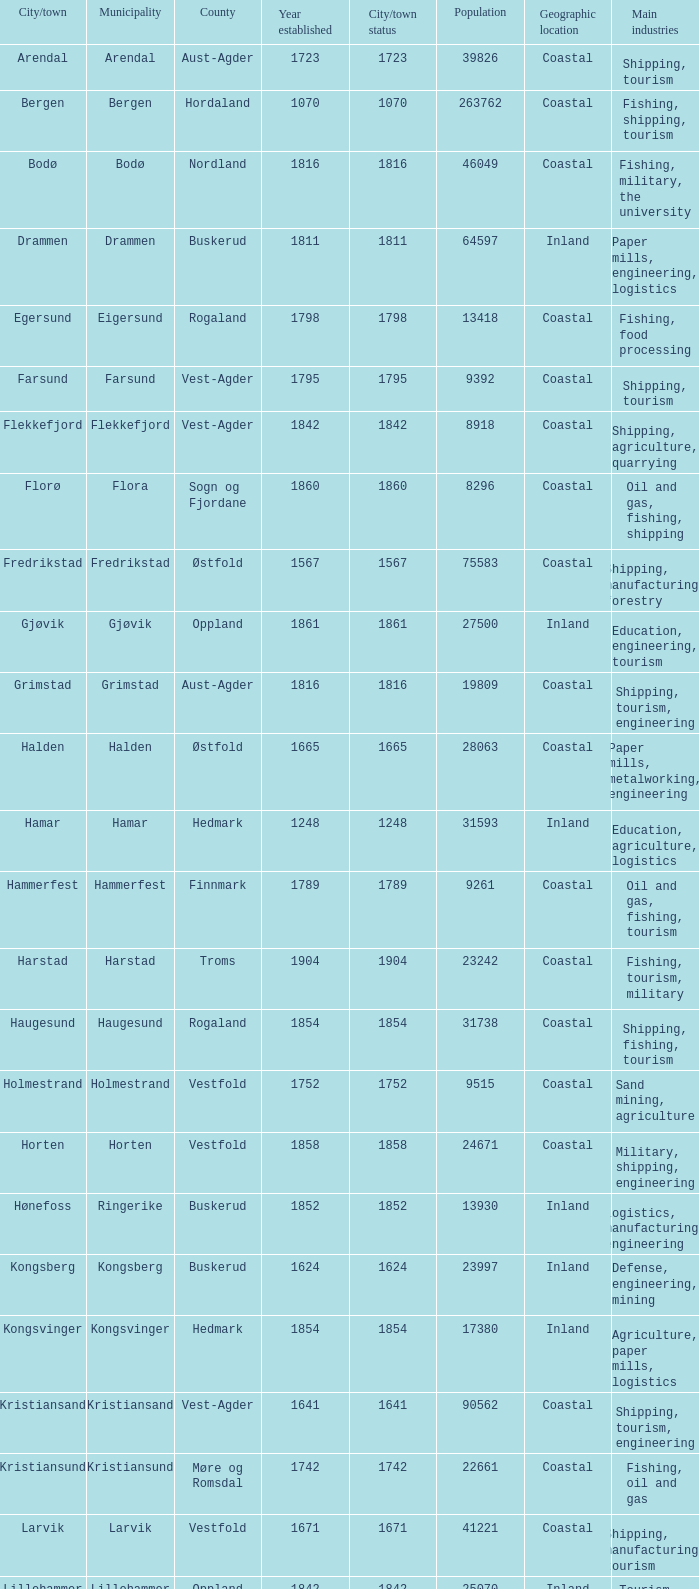What is the total population in the city/town of Arendal? 1.0. 